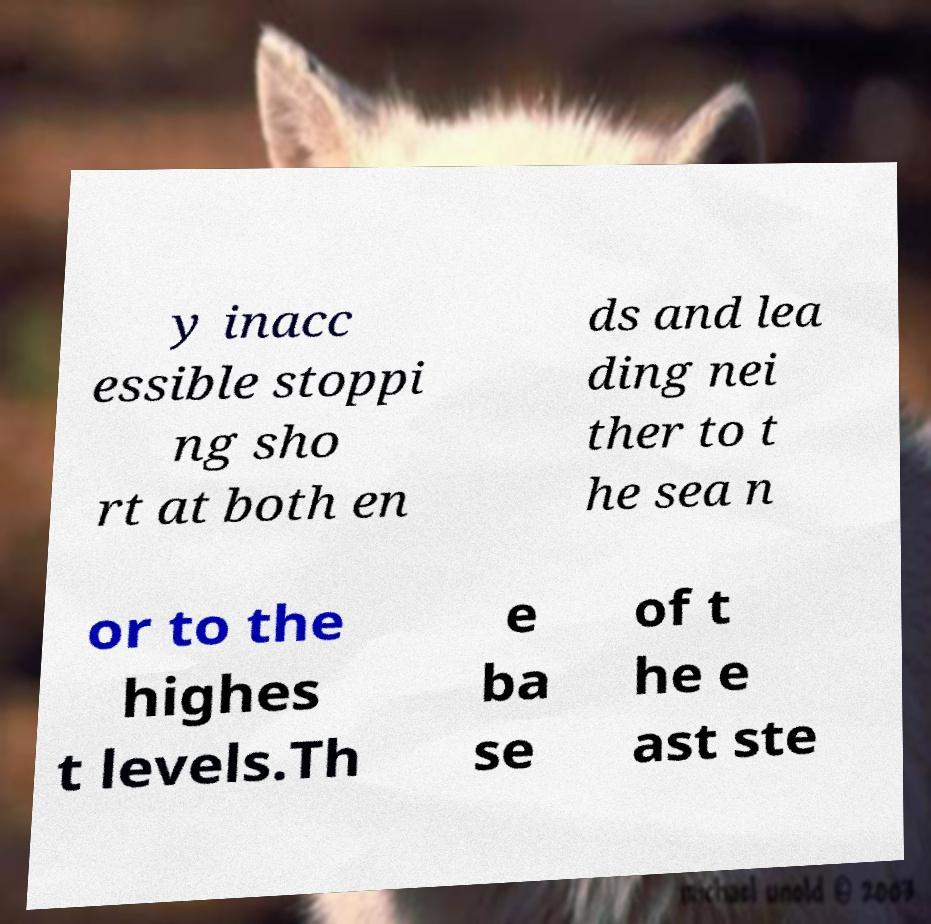There's text embedded in this image that I need extracted. Can you transcribe it verbatim? y inacc essible stoppi ng sho rt at both en ds and lea ding nei ther to t he sea n or to the highes t levels.Th e ba se of t he e ast ste 